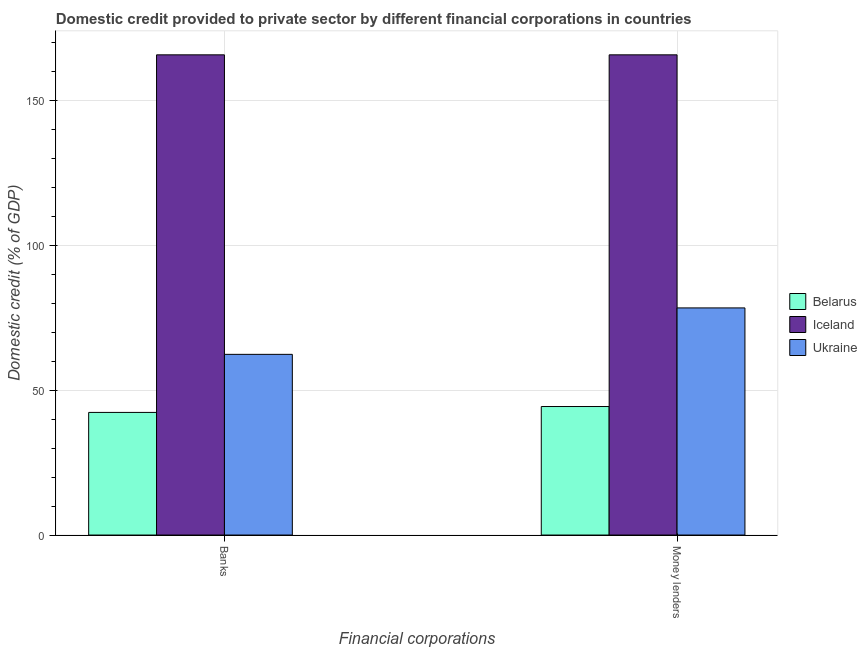How many different coloured bars are there?
Keep it short and to the point. 3. How many groups of bars are there?
Provide a short and direct response. 2. Are the number of bars on each tick of the X-axis equal?
Provide a succinct answer. Yes. How many bars are there on the 2nd tick from the right?
Provide a short and direct response. 3. What is the label of the 2nd group of bars from the left?
Offer a very short reply. Money lenders. What is the domestic credit provided by banks in Belarus?
Provide a succinct answer. 42.33. Across all countries, what is the maximum domestic credit provided by money lenders?
Your answer should be very brief. 165.78. Across all countries, what is the minimum domestic credit provided by money lenders?
Provide a short and direct response. 44.37. In which country was the domestic credit provided by money lenders maximum?
Give a very brief answer. Iceland. In which country was the domestic credit provided by banks minimum?
Provide a succinct answer. Belarus. What is the total domestic credit provided by money lenders in the graph?
Your response must be concise. 288.57. What is the difference between the domestic credit provided by money lenders in Belarus and that in Iceland?
Provide a short and direct response. -121.41. What is the difference between the domestic credit provided by money lenders in Ukraine and the domestic credit provided by banks in Belarus?
Provide a succinct answer. 36.08. What is the average domestic credit provided by banks per country?
Offer a terse response. 90.17. What is the difference between the domestic credit provided by money lenders and domestic credit provided by banks in Iceland?
Ensure brevity in your answer.  0. In how many countries, is the domestic credit provided by banks greater than 10 %?
Ensure brevity in your answer.  3. What is the ratio of the domestic credit provided by banks in Ukraine to that in Belarus?
Your answer should be very brief. 1.47. Is the domestic credit provided by banks in Ukraine less than that in Iceland?
Provide a succinct answer. Yes. In how many countries, is the domestic credit provided by banks greater than the average domestic credit provided by banks taken over all countries?
Ensure brevity in your answer.  1. What does the 3rd bar from the left in Banks represents?
Your answer should be very brief. Ukraine. How many bars are there?
Provide a short and direct response. 6. Are all the bars in the graph horizontal?
Keep it short and to the point. No. Does the graph contain any zero values?
Your answer should be very brief. No. How many legend labels are there?
Ensure brevity in your answer.  3. How are the legend labels stacked?
Offer a very short reply. Vertical. What is the title of the graph?
Your answer should be compact. Domestic credit provided to private sector by different financial corporations in countries. Does "Guyana" appear as one of the legend labels in the graph?
Offer a terse response. No. What is the label or title of the X-axis?
Your answer should be very brief. Financial corporations. What is the label or title of the Y-axis?
Your answer should be compact. Domestic credit (% of GDP). What is the Domestic credit (% of GDP) in Belarus in Banks?
Your response must be concise. 42.33. What is the Domestic credit (% of GDP) of Iceland in Banks?
Your answer should be compact. 165.78. What is the Domestic credit (% of GDP) in Ukraine in Banks?
Provide a short and direct response. 62.38. What is the Domestic credit (% of GDP) of Belarus in Money lenders?
Make the answer very short. 44.37. What is the Domestic credit (% of GDP) in Iceland in Money lenders?
Make the answer very short. 165.78. What is the Domestic credit (% of GDP) in Ukraine in Money lenders?
Offer a terse response. 78.41. Across all Financial corporations, what is the maximum Domestic credit (% of GDP) in Belarus?
Ensure brevity in your answer.  44.37. Across all Financial corporations, what is the maximum Domestic credit (% of GDP) of Iceland?
Provide a succinct answer. 165.78. Across all Financial corporations, what is the maximum Domestic credit (% of GDP) of Ukraine?
Your response must be concise. 78.41. Across all Financial corporations, what is the minimum Domestic credit (% of GDP) in Belarus?
Keep it short and to the point. 42.33. Across all Financial corporations, what is the minimum Domestic credit (% of GDP) of Iceland?
Keep it short and to the point. 165.78. Across all Financial corporations, what is the minimum Domestic credit (% of GDP) of Ukraine?
Your answer should be very brief. 62.38. What is the total Domestic credit (% of GDP) in Belarus in the graph?
Offer a very short reply. 86.7. What is the total Domestic credit (% of GDP) of Iceland in the graph?
Keep it short and to the point. 331.57. What is the total Domestic credit (% of GDP) in Ukraine in the graph?
Give a very brief answer. 140.79. What is the difference between the Domestic credit (% of GDP) of Belarus in Banks and that in Money lenders?
Ensure brevity in your answer.  -2.04. What is the difference between the Domestic credit (% of GDP) in Iceland in Banks and that in Money lenders?
Offer a terse response. 0. What is the difference between the Domestic credit (% of GDP) in Ukraine in Banks and that in Money lenders?
Offer a terse response. -16.03. What is the difference between the Domestic credit (% of GDP) of Belarus in Banks and the Domestic credit (% of GDP) of Iceland in Money lenders?
Make the answer very short. -123.45. What is the difference between the Domestic credit (% of GDP) in Belarus in Banks and the Domestic credit (% of GDP) in Ukraine in Money lenders?
Your answer should be very brief. -36.08. What is the difference between the Domestic credit (% of GDP) in Iceland in Banks and the Domestic credit (% of GDP) in Ukraine in Money lenders?
Make the answer very short. 87.37. What is the average Domestic credit (% of GDP) of Belarus per Financial corporations?
Give a very brief answer. 43.35. What is the average Domestic credit (% of GDP) of Iceland per Financial corporations?
Give a very brief answer. 165.78. What is the average Domestic credit (% of GDP) of Ukraine per Financial corporations?
Offer a terse response. 70.4. What is the difference between the Domestic credit (% of GDP) in Belarus and Domestic credit (% of GDP) in Iceland in Banks?
Offer a very short reply. -123.45. What is the difference between the Domestic credit (% of GDP) in Belarus and Domestic credit (% of GDP) in Ukraine in Banks?
Make the answer very short. -20.05. What is the difference between the Domestic credit (% of GDP) of Iceland and Domestic credit (% of GDP) of Ukraine in Banks?
Make the answer very short. 103.4. What is the difference between the Domestic credit (% of GDP) in Belarus and Domestic credit (% of GDP) in Iceland in Money lenders?
Give a very brief answer. -121.41. What is the difference between the Domestic credit (% of GDP) of Belarus and Domestic credit (% of GDP) of Ukraine in Money lenders?
Your answer should be very brief. -34.04. What is the difference between the Domestic credit (% of GDP) of Iceland and Domestic credit (% of GDP) of Ukraine in Money lenders?
Make the answer very short. 87.37. What is the ratio of the Domestic credit (% of GDP) in Belarus in Banks to that in Money lenders?
Your answer should be very brief. 0.95. What is the ratio of the Domestic credit (% of GDP) in Ukraine in Banks to that in Money lenders?
Your answer should be very brief. 0.8. What is the difference between the highest and the second highest Domestic credit (% of GDP) of Belarus?
Give a very brief answer. 2.04. What is the difference between the highest and the second highest Domestic credit (% of GDP) of Ukraine?
Offer a very short reply. 16.03. What is the difference between the highest and the lowest Domestic credit (% of GDP) of Belarus?
Your response must be concise. 2.04. What is the difference between the highest and the lowest Domestic credit (% of GDP) in Ukraine?
Offer a terse response. 16.03. 